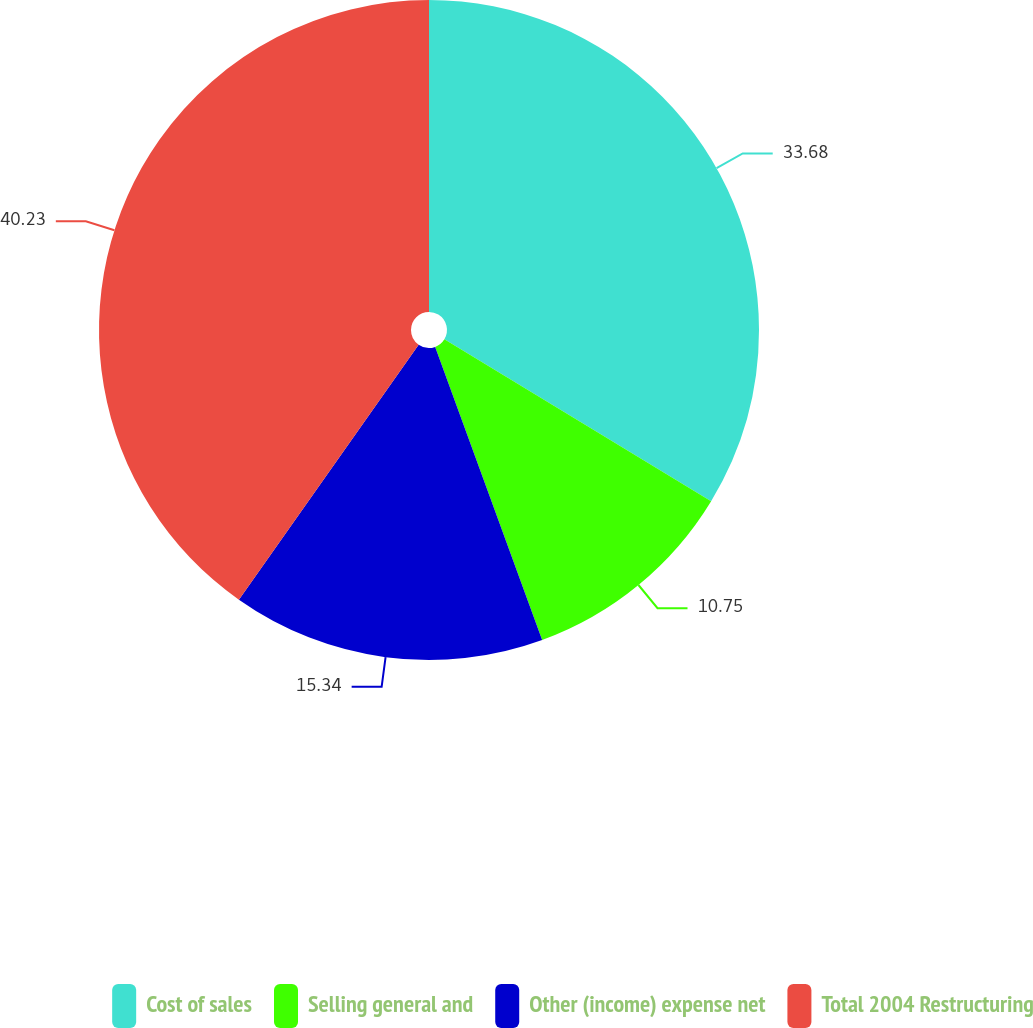Convert chart. <chart><loc_0><loc_0><loc_500><loc_500><pie_chart><fcel>Cost of sales<fcel>Selling general and<fcel>Other (income) expense net<fcel>Total 2004 Restructuring<nl><fcel>33.68%<fcel>10.75%<fcel>15.34%<fcel>40.23%<nl></chart> 